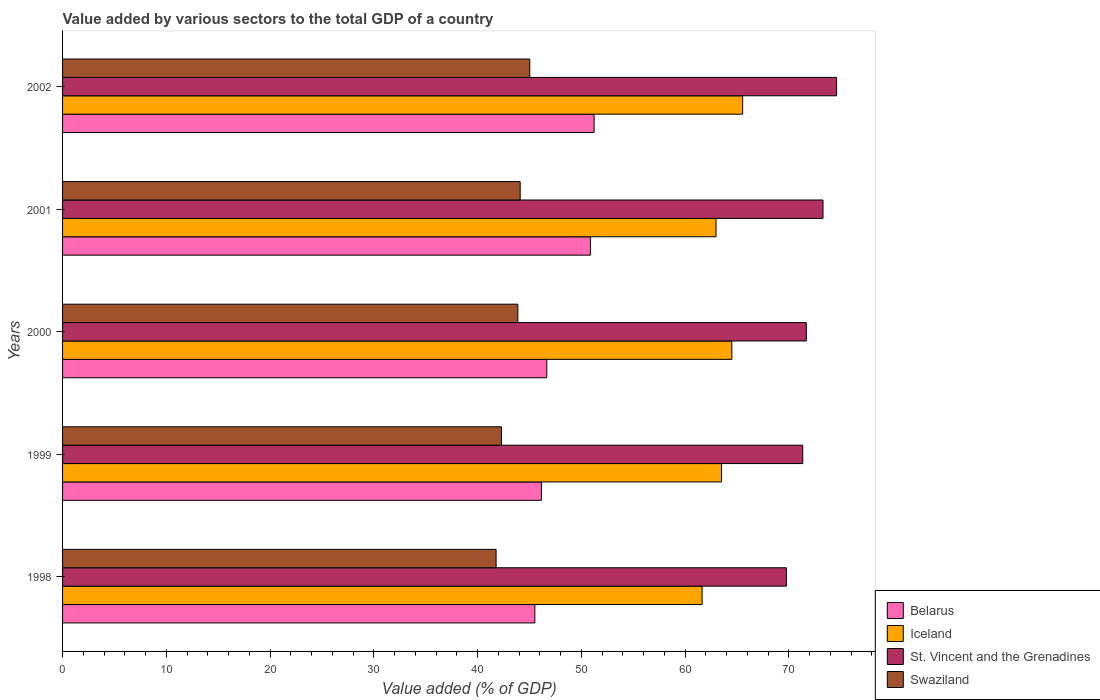How many groups of bars are there?
Make the answer very short. 5. Are the number of bars on each tick of the Y-axis equal?
Ensure brevity in your answer.  Yes. How many bars are there on the 1st tick from the top?
Give a very brief answer. 4. What is the label of the 1st group of bars from the top?
Provide a short and direct response. 2002. What is the value added by various sectors to the total GDP in Iceland in 2002?
Provide a succinct answer. 65.56. Across all years, what is the maximum value added by various sectors to the total GDP in Swaziland?
Give a very brief answer. 45.04. Across all years, what is the minimum value added by various sectors to the total GDP in Belarus?
Give a very brief answer. 45.52. What is the total value added by various sectors to the total GDP in St. Vincent and the Grenadines in the graph?
Offer a very short reply. 360.72. What is the difference between the value added by various sectors to the total GDP in St. Vincent and the Grenadines in 1999 and that in 2002?
Offer a very short reply. -3.26. What is the difference between the value added by various sectors to the total GDP in St. Vincent and the Grenadines in 2001 and the value added by various sectors to the total GDP in Iceland in 1999?
Keep it short and to the point. 9.78. What is the average value added by various sectors to the total GDP in St. Vincent and the Grenadines per year?
Offer a very short reply. 72.14. In the year 2001, what is the difference between the value added by various sectors to the total GDP in St. Vincent and the Grenadines and value added by various sectors to the total GDP in Swaziland?
Your answer should be very brief. 29.19. In how many years, is the value added by various sectors to the total GDP in Iceland greater than 44 %?
Make the answer very short. 5. What is the ratio of the value added by various sectors to the total GDP in Swaziland in 1998 to that in 2000?
Give a very brief answer. 0.95. Is the difference between the value added by various sectors to the total GDP in St. Vincent and the Grenadines in 2000 and 2001 greater than the difference between the value added by various sectors to the total GDP in Swaziland in 2000 and 2001?
Ensure brevity in your answer.  No. What is the difference between the highest and the second highest value added by various sectors to the total GDP in Belarus?
Your answer should be very brief. 0.36. What is the difference between the highest and the lowest value added by various sectors to the total GDP in Iceland?
Your answer should be compact. 3.91. Is it the case that in every year, the sum of the value added by various sectors to the total GDP in Swaziland and value added by various sectors to the total GDP in Iceland is greater than the sum of value added by various sectors to the total GDP in St. Vincent and the Grenadines and value added by various sectors to the total GDP in Belarus?
Your response must be concise. Yes. What does the 2nd bar from the top in 1999 represents?
Offer a terse response. St. Vincent and the Grenadines. Is it the case that in every year, the sum of the value added by various sectors to the total GDP in St. Vincent and the Grenadines and value added by various sectors to the total GDP in Swaziland is greater than the value added by various sectors to the total GDP in Iceland?
Offer a very short reply. Yes. How many bars are there?
Your answer should be very brief. 20. Are all the bars in the graph horizontal?
Offer a very short reply. Yes. How many years are there in the graph?
Offer a very short reply. 5. What is the difference between two consecutive major ticks on the X-axis?
Ensure brevity in your answer.  10. Are the values on the major ticks of X-axis written in scientific E-notation?
Make the answer very short. No. Does the graph contain any zero values?
Your answer should be compact. No. How many legend labels are there?
Offer a very short reply. 4. What is the title of the graph?
Offer a very short reply. Value added by various sectors to the total GDP of a country. Does "South Sudan" appear as one of the legend labels in the graph?
Provide a succinct answer. No. What is the label or title of the X-axis?
Your response must be concise. Value added (% of GDP). What is the label or title of the Y-axis?
Give a very brief answer. Years. What is the Value added (% of GDP) in Belarus in 1998?
Make the answer very short. 45.52. What is the Value added (% of GDP) of Iceland in 1998?
Give a very brief answer. 61.65. What is the Value added (% of GDP) in St. Vincent and the Grenadines in 1998?
Provide a succinct answer. 69.77. What is the Value added (% of GDP) of Swaziland in 1998?
Your answer should be compact. 41.79. What is the Value added (% of GDP) of Belarus in 1999?
Offer a very short reply. 46.16. What is the Value added (% of GDP) of Iceland in 1999?
Give a very brief answer. 63.52. What is the Value added (% of GDP) of St. Vincent and the Grenadines in 1999?
Your answer should be compact. 71.35. What is the Value added (% of GDP) of Swaziland in 1999?
Your answer should be compact. 42.31. What is the Value added (% of GDP) of Belarus in 2000?
Offer a terse response. 46.68. What is the Value added (% of GDP) of Iceland in 2000?
Give a very brief answer. 64.51. What is the Value added (% of GDP) in St. Vincent and the Grenadines in 2000?
Ensure brevity in your answer.  71.69. What is the Value added (% of GDP) in Swaziland in 2000?
Offer a very short reply. 43.88. What is the Value added (% of GDP) of Belarus in 2001?
Your answer should be very brief. 50.88. What is the Value added (% of GDP) of Iceland in 2001?
Your response must be concise. 62.99. What is the Value added (% of GDP) of St. Vincent and the Grenadines in 2001?
Provide a short and direct response. 73.3. What is the Value added (% of GDP) of Swaziland in 2001?
Give a very brief answer. 44.11. What is the Value added (% of GDP) in Belarus in 2002?
Provide a succinct answer. 51.24. What is the Value added (% of GDP) of Iceland in 2002?
Keep it short and to the point. 65.56. What is the Value added (% of GDP) in St. Vincent and the Grenadines in 2002?
Offer a very short reply. 74.61. What is the Value added (% of GDP) in Swaziland in 2002?
Your response must be concise. 45.04. Across all years, what is the maximum Value added (% of GDP) of Belarus?
Your answer should be compact. 51.24. Across all years, what is the maximum Value added (% of GDP) of Iceland?
Your answer should be very brief. 65.56. Across all years, what is the maximum Value added (% of GDP) of St. Vincent and the Grenadines?
Keep it short and to the point. 74.61. Across all years, what is the maximum Value added (% of GDP) of Swaziland?
Offer a terse response. 45.04. Across all years, what is the minimum Value added (% of GDP) in Belarus?
Make the answer very short. 45.52. Across all years, what is the minimum Value added (% of GDP) of Iceland?
Give a very brief answer. 61.65. Across all years, what is the minimum Value added (% of GDP) in St. Vincent and the Grenadines?
Your answer should be very brief. 69.77. Across all years, what is the minimum Value added (% of GDP) in Swaziland?
Provide a short and direct response. 41.79. What is the total Value added (% of GDP) of Belarus in the graph?
Your answer should be very brief. 240.47. What is the total Value added (% of GDP) of Iceland in the graph?
Make the answer very short. 318.22. What is the total Value added (% of GDP) of St. Vincent and the Grenadines in the graph?
Offer a terse response. 360.72. What is the total Value added (% of GDP) in Swaziland in the graph?
Provide a succinct answer. 217.13. What is the difference between the Value added (% of GDP) of Belarus in 1998 and that in 1999?
Give a very brief answer. -0.63. What is the difference between the Value added (% of GDP) in Iceland in 1998 and that in 1999?
Keep it short and to the point. -1.87. What is the difference between the Value added (% of GDP) in St. Vincent and the Grenadines in 1998 and that in 1999?
Your response must be concise. -1.58. What is the difference between the Value added (% of GDP) in Swaziland in 1998 and that in 1999?
Offer a terse response. -0.52. What is the difference between the Value added (% of GDP) of Belarus in 1998 and that in 2000?
Offer a very short reply. -1.15. What is the difference between the Value added (% of GDP) in Iceland in 1998 and that in 2000?
Provide a short and direct response. -2.87. What is the difference between the Value added (% of GDP) in St. Vincent and the Grenadines in 1998 and that in 2000?
Keep it short and to the point. -1.92. What is the difference between the Value added (% of GDP) of Swaziland in 1998 and that in 2000?
Your answer should be compact. -2.1. What is the difference between the Value added (% of GDP) of Belarus in 1998 and that in 2001?
Offer a very short reply. -5.36. What is the difference between the Value added (% of GDP) of Iceland in 1998 and that in 2001?
Ensure brevity in your answer.  -1.34. What is the difference between the Value added (% of GDP) of St. Vincent and the Grenadines in 1998 and that in 2001?
Offer a very short reply. -3.53. What is the difference between the Value added (% of GDP) of Swaziland in 1998 and that in 2001?
Offer a very short reply. -2.32. What is the difference between the Value added (% of GDP) in Belarus in 1998 and that in 2002?
Keep it short and to the point. -5.71. What is the difference between the Value added (% of GDP) of Iceland in 1998 and that in 2002?
Offer a very short reply. -3.91. What is the difference between the Value added (% of GDP) of St. Vincent and the Grenadines in 1998 and that in 2002?
Offer a very short reply. -4.84. What is the difference between the Value added (% of GDP) in Swaziland in 1998 and that in 2002?
Provide a succinct answer. -3.25. What is the difference between the Value added (% of GDP) in Belarus in 1999 and that in 2000?
Offer a very short reply. -0.52. What is the difference between the Value added (% of GDP) in Iceland in 1999 and that in 2000?
Give a very brief answer. -0.99. What is the difference between the Value added (% of GDP) of St. Vincent and the Grenadines in 1999 and that in 2000?
Your response must be concise. -0.35. What is the difference between the Value added (% of GDP) in Swaziland in 1999 and that in 2000?
Your answer should be compact. -1.58. What is the difference between the Value added (% of GDP) in Belarus in 1999 and that in 2001?
Offer a very short reply. -4.72. What is the difference between the Value added (% of GDP) of Iceland in 1999 and that in 2001?
Offer a very short reply. 0.53. What is the difference between the Value added (% of GDP) in St. Vincent and the Grenadines in 1999 and that in 2001?
Provide a short and direct response. -1.95. What is the difference between the Value added (% of GDP) of Swaziland in 1999 and that in 2001?
Keep it short and to the point. -1.8. What is the difference between the Value added (% of GDP) in Belarus in 1999 and that in 2002?
Your response must be concise. -5.08. What is the difference between the Value added (% of GDP) of Iceland in 1999 and that in 2002?
Keep it short and to the point. -2.04. What is the difference between the Value added (% of GDP) of St. Vincent and the Grenadines in 1999 and that in 2002?
Your answer should be very brief. -3.26. What is the difference between the Value added (% of GDP) in Swaziland in 1999 and that in 2002?
Give a very brief answer. -2.73. What is the difference between the Value added (% of GDP) in Belarus in 2000 and that in 2001?
Your response must be concise. -4.2. What is the difference between the Value added (% of GDP) of Iceland in 2000 and that in 2001?
Offer a very short reply. 1.52. What is the difference between the Value added (% of GDP) in St. Vincent and the Grenadines in 2000 and that in 2001?
Make the answer very short. -1.61. What is the difference between the Value added (% of GDP) in Swaziland in 2000 and that in 2001?
Your answer should be very brief. -0.23. What is the difference between the Value added (% of GDP) in Belarus in 2000 and that in 2002?
Offer a terse response. -4.56. What is the difference between the Value added (% of GDP) of Iceland in 2000 and that in 2002?
Keep it short and to the point. -1.04. What is the difference between the Value added (% of GDP) of St. Vincent and the Grenadines in 2000 and that in 2002?
Make the answer very short. -2.92. What is the difference between the Value added (% of GDP) of Swaziland in 2000 and that in 2002?
Provide a succinct answer. -1.15. What is the difference between the Value added (% of GDP) in Belarus in 2001 and that in 2002?
Your answer should be very brief. -0.36. What is the difference between the Value added (% of GDP) in Iceland in 2001 and that in 2002?
Provide a succinct answer. -2.57. What is the difference between the Value added (% of GDP) of St. Vincent and the Grenadines in 2001 and that in 2002?
Your response must be concise. -1.31. What is the difference between the Value added (% of GDP) in Swaziland in 2001 and that in 2002?
Your answer should be compact. -0.93. What is the difference between the Value added (% of GDP) of Belarus in 1998 and the Value added (% of GDP) of Iceland in 1999?
Offer a very short reply. -18. What is the difference between the Value added (% of GDP) of Belarus in 1998 and the Value added (% of GDP) of St. Vincent and the Grenadines in 1999?
Your response must be concise. -25.82. What is the difference between the Value added (% of GDP) of Belarus in 1998 and the Value added (% of GDP) of Swaziland in 1999?
Your answer should be compact. 3.22. What is the difference between the Value added (% of GDP) in Iceland in 1998 and the Value added (% of GDP) in St. Vincent and the Grenadines in 1999?
Offer a very short reply. -9.7. What is the difference between the Value added (% of GDP) in Iceland in 1998 and the Value added (% of GDP) in Swaziland in 1999?
Keep it short and to the point. 19.34. What is the difference between the Value added (% of GDP) of St. Vincent and the Grenadines in 1998 and the Value added (% of GDP) of Swaziland in 1999?
Your response must be concise. 27.46. What is the difference between the Value added (% of GDP) in Belarus in 1998 and the Value added (% of GDP) in Iceland in 2000?
Provide a short and direct response. -18.99. What is the difference between the Value added (% of GDP) of Belarus in 1998 and the Value added (% of GDP) of St. Vincent and the Grenadines in 2000?
Keep it short and to the point. -26.17. What is the difference between the Value added (% of GDP) in Belarus in 1998 and the Value added (% of GDP) in Swaziland in 2000?
Provide a short and direct response. 1.64. What is the difference between the Value added (% of GDP) of Iceland in 1998 and the Value added (% of GDP) of St. Vincent and the Grenadines in 2000?
Ensure brevity in your answer.  -10.05. What is the difference between the Value added (% of GDP) in Iceland in 1998 and the Value added (% of GDP) in Swaziland in 2000?
Your answer should be very brief. 17.76. What is the difference between the Value added (% of GDP) of St. Vincent and the Grenadines in 1998 and the Value added (% of GDP) of Swaziland in 2000?
Ensure brevity in your answer.  25.89. What is the difference between the Value added (% of GDP) of Belarus in 1998 and the Value added (% of GDP) of Iceland in 2001?
Make the answer very short. -17.46. What is the difference between the Value added (% of GDP) of Belarus in 1998 and the Value added (% of GDP) of St. Vincent and the Grenadines in 2001?
Keep it short and to the point. -27.78. What is the difference between the Value added (% of GDP) in Belarus in 1998 and the Value added (% of GDP) in Swaziland in 2001?
Provide a short and direct response. 1.41. What is the difference between the Value added (% of GDP) of Iceland in 1998 and the Value added (% of GDP) of St. Vincent and the Grenadines in 2001?
Ensure brevity in your answer.  -11.66. What is the difference between the Value added (% of GDP) of Iceland in 1998 and the Value added (% of GDP) of Swaziland in 2001?
Ensure brevity in your answer.  17.54. What is the difference between the Value added (% of GDP) of St. Vincent and the Grenadines in 1998 and the Value added (% of GDP) of Swaziland in 2001?
Offer a terse response. 25.66. What is the difference between the Value added (% of GDP) of Belarus in 1998 and the Value added (% of GDP) of Iceland in 2002?
Offer a terse response. -20.03. What is the difference between the Value added (% of GDP) in Belarus in 1998 and the Value added (% of GDP) in St. Vincent and the Grenadines in 2002?
Your answer should be very brief. -29.09. What is the difference between the Value added (% of GDP) of Belarus in 1998 and the Value added (% of GDP) of Swaziland in 2002?
Provide a short and direct response. 0.49. What is the difference between the Value added (% of GDP) in Iceland in 1998 and the Value added (% of GDP) in St. Vincent and the Grenadines in 2002?
Make the answer very short. -12.96. What is the difference between the Value added (% of GDP) of Iceland in 1998 and the Value added (% of GDP) of Swaziland in 2002?
Make the answer very short. 16.61. What is the difference between the Value added (% of GDP) in St. Vincent and the Grenadines in 1998 and the Value added (% of GDP) in Swaziland in 2002?
Your answer should be very brief. 24.73. What is the difference between the Value added (% of GDP) of Belarus in 1999 and the Value added (% of GDP) of Iceland in 2000?
Your answer should be compact. -18.36. What is the difference between the Value added (% of GDP) of Belarus in 1999 and the Value added (% of GDP) of St. Vincent and the Grenadines in 2000?
Make the answer very short. -25.54. What is the difference between the Value added (% of GDP) in Belarus in 1999 and the Value added (% of GDP) in Swaziland in 2000?
Keep it short and to the point. 2.27. What is the difference between the Value added (% of GDP) in Iceland in 1999 and the Value added (% of GDP) in St. Vincent and the Grenadines in 2000?
Offer a terse response. -8.17. What is the difference between the Value added (% of GDP) of Iceland in 1999 and the Value added (% of GDP) of Swaziland in 2000?
Your response must be concise. 19.63. What is the difference between the Value added (% of GDP) of St. Vincent and the Grenadines in 1999 and the Value added (% of GDP) of Swaziland in 2000?
Offer a terse response. 27.46. What is the difference between the Value added (% of GDP) of Belarus in 1999 and the Value added (% of GDP) of Iceland in 2001?
Make the answer very short. -16.83. What is the difference between the Value added (% of GDP) of Belarus in 1999 and the Value added (% of GDP) of St. Vincent and the Grenadines in 2001?
Provide a short and direct response. -27.15. What is the difference between the Value added (% of GDP) of Belarus in 1999 and the Value added (% of GDP) of Swaziland in 2001?
Ensure brevity in your answer.  2.05. What is the difference between the Value added (% of GDP) in Iceland in 1999 and the Value added (% of GDP) in St. Vincent and the Grenadines in 2001?
Your response must be concise. -9.78. What is the difference between the Value added (% of GDP) of Iceland in 1999 and the Value added (% of GDP) of Swaziland in 2001?
Make the answer very short. 19.41. What is the difference between the Value added (% of GDP) in St. Vincent and the Grenadines in 1999 and the Value added (% of GDP) in Swaziland in 2001?
Your answer should be very brief. 27.24. What is the difference between the Value added (% of GDP) in Belarus in 1999 and the Value added (% of GDP) in Iceland in 2002?
Make the answer very short. -19.4. What is the difference between the Value added (% of GDP) of Belarus in 1999 and the Value added (% of GDP) of St. Vincent and the Grenadines in 2002?
Provide a short and direct response. -28.45. What is the difference between the Value added (% of GDP) of Belarus in 1999 and the Value added (% of GDP) of Swaziland in 2002?
Give a very brief answer. 1.12. What is the difference between the Value added (% of GDP) of Iceland in 1999 and the Value added (% of GDP) of St. Vincent and the Grenadines in 2002?
Your answer should be very brief. -11.09. What is the difference between the Value added (% of GDP) of Iceland in 1999 and the Value added (% of GDP) of Swaziland in 2002?
Ensure brevity in your answer.  18.48. What is the difference between the Value added (% of GDP) in St. Vincent and the Grenadines in 1999 and the Value added (% of GDP) in Swaziland in 2002?
Make the answer very short. 26.31. What is the difference between the Value added (% of GDP) in Belarus in 2000 and the Value added (% of GDP) in Iceland in 2001?
Your answer should be very brief. -16.31. What is the difference between the Value added (% of GDP) in Belarus in 2000 and the Value added (% of GDP) in St. Vincent and the Grenadines in 2001?
Provide a short and direct response. -26.63. What is the difference between the Value added (% of GDP) of Belarus in 2000 and the Value added (% of GDP) of Swaziland in 2001?
Give a very brief answer. 2.57. What is the difference between the Value added (% of GDP) in Iceland in 2000 and the Value added (% of GDP) in St. Vincent and the Grenadines in 2001?
Offer a terse response. -8.79. What is the difference between the Value added (% of GDP) in Iceland in 2000 and the Value added (% of GDP) in Swaziland in 2001?
Provide a short and direct response. 20.4. What is the difference between the Value added (% of GDP) in St. Vincent and the Grenadines in 2000 and the Value added (% of GDP) in Swaziland in 2001?
Make the answer very short. 27.58. What is the difference between the Value added (% of GDP) of Belarus in 2000 and the Value added (% of GDP) of Iceland in 2002?
Provide a short and direct response. -18.88. What is the difference between the Value added (% of GDP) in Belarus in 2000 and the Value added (% of GDP) in St. Vincent and the Grenadines in 2002?
Provide a succinct answer. -27.93. What is the difference between the Value added (% of GDP) in Belarus in 2000 and the Value added (% of GDP) in Swaziland in 2002?
Give a very brief answer. 1.64. What is the difference between the Value added (% of GDP) of Iceland in 2000 and the Value added (% of GDP) of St. Vincent and the Grenadines in 2002?
Make the answer very short. -10.1. What is the difference between the Value added (% of GDP) in Iceland in 2000 and the Value added (% of GDP) in Swaziland in 2002?
Ensure brevity in your answer.  19.48. What is the difference between the Value added (% of GDP) in St. Vincent and the Grenadines in 2000 and the Value added (% of GDP) in Swaziland in 2002?
Your answer should be compact. 26.66. What is the difference between the Value added (% of GDP) in Belarus in 2001 and the Value added (% of GDP) in Iceland in 2002?
Offer a terse response. -14.68. What is the difference between the Value added (% of GDP) in Belarus in 2001 and the Value added (% of GDP) in St. Vincent and the Grenadines in 2002?
Your answer should be compact. -23.73. What is the difference between the Value added (% of GDP) in Belarus in 2001 and the Value added (% of GDP) in Swaziland in 2002?
Make the answer very short. 5.84. What is the difference between the Value added (% of GDP) in Iceland in 2001 and the Value added (% of GDP) in St. Vincent and the Grenadines in 2002?
Your answer should be compact. -11.62. What is the difference between the Value added (% of GDP) of Iceland in 2001 and the Value added (% of GDP) of Swaziland in 2002?
Provide a succinct answer. 17.95. What is the difference between the Value added (% of GDP) of St. Vincent and the Grenadines in 2001 and the Value added (% of GDP) of Swaziland in 2002?
Give a very brief answer. 28.27. What is the average Value added (% of GDP) of Belarus per year?
Offer a terse response. 48.09. What is the average Value added (% of GDP) in Iceland per year?
Give a very brief answer. 63.64. What is the average Value added (% of GDP) in St. Vincent and the Grenadines per year?
Provide a succinct answer. 72.14. What is the average Value added (% of GDP) in Swaziland per year?
Your response must be concise. 43.43. In the year 1998, what is the difference between the Value added (% of GDP) in Belarus and Value added (% of GDP) in Iceland?
Provide a succinct answer. -16.12. In the year 1998, what is the difference between the Value added (% of GDP) in Belarus and Value added (% of GDP) in St. Vincent and the Grenadines?
Provide a succinct answer. -24.25. In the year 1998, what is the difference between the Value added (% of GDP) of Belarus and Value added (% of GDP) of Swaziland?
Provide a succinct answer. 3.74. In the year 1998, what is the difference between the Value added (% of GDP) of Iceland and Value added (% of GDP) of St. Vincent and the Grenadines?
Your response must be concise. -8.12. In the year 1998, what is the difference between the Value added (% of GDP) in Iceland and Value added (% of GDP) in Swaziland?
Ensure brevity in your answer.  19.86. In the year 1998, what is the difference between the Value added (% of GDP) of St. Vincent and the Grenadines and Value added (% of GDP) of Swaziland?
Give a very brief answer. 27.98. In the year 1999, what is the difference between the Value added (% of GDP) in Belarus and Value added (% of GDP) in Iceland?
Provide a succinct answer. -17.36. In the year 1999, what is the difference between the Value added (% of GDP) in Belarus and Value added (% of GDP) in St. Vincent and the Grenadines?
Make the answer very short. -25.19. In the year 1999, what is the difference between the Value added (% of GDP) in Belarus and Value added (% of GDP) in Swaziland?
Your answer should be very brief. 3.85. In the year 1999, what is the difference between the Value added (% of GDP) in Iceland and Value added (% of GDP) in St. Vincent and the Grenadines?
Offer a terse response. -7.83. In the year 1999, what is the difference between the Value added (% of GDP) of Iceland and Value added (% of GDP) of Swaziland?
Your answer should be very brief. 21.21. In the year 1999, what is the difference between the Value added (% of GDP) of St. Vincent and the Grenadines and Value added (% of GDP) of Swaziland?
Offer a terse response. 29.04. In the year 2000, what is the difference between the Value added (% of GDP) in Belarus and Value added (% of GDP) in Iceland?
Keep it short and to the point. -17.84. In the year 2000, what is the difference between the Value added (% of GDP) in Belarus and Value added (% of GDP) in St. Vincent and the Grenadines?
Make the answer very short. -25.02. In the year 2000, what is the difference between the Value added (% of GDP) in Belarus and Value added (% of GDP) in Swaziland?
Provide a succinct answer. 2.79. In the year 2000, what is the difference between the Value added (% of GDP) in Iceland and Value added (% of GDP) in St. Vincent and the Grenadines?
Offer a terse response. -7.18. In the year 2000, what is the difference between the Value added (% of GDP) in Iceland and Value added (% of GDP) in Swaziland?
Provide a succinct answer. 20.63. In the year 2000, what is the difference between the Value added (% of GDP) of St. Vincent and the Grenadines and Value added (% of GDP) of Swaziland?
Make the answer very short. 27.81. In the year 2001, what is the difference between the Value added (% of GDP) of Belarus and Value added (% of GDP) of Iceland?
Your answer should be very brief. -12.11. In the year 2001, what is the difference between the Value added (% of GDP) of Belarus and Value added (% of GDP) of St. Vincent and the Grenadines?
Offer a very short reply. -22.42. In the year 2001, what is the difference between the Value added (% of GDP) of Belarus and Value added (% of GDP) of Swaziland?
Give a very brief answer. 6.77. In the year 2001, what is the difference between the Value added (% of GDP) in Iceland and Value added (% of GDP) in St. Vincent and the Grenadines?
Ensure brevity in your answer.  -10.31. In the year 2001, what is the difference between the Value added (% of GDP) in Iceland and Value added (% of GDP) in Swaziland?
Your answer should be compact. 18.88. In the year 2001, what is the difference between the Value added (% of GDP) in St. Vincent and the Grenadines and Value added (% of GDP) in Swaziland?
Ensure brevity in your answer.  29.19. In the year 2002, what is the difference between the Value added (% of GDP) of Belarus and Value added (% of GDP) of Iceland?
Give a very brief answer. -14.32. In the year 2002, what is the difference between the Value added (% of GDP) in Belarus and Value added (% of GDP) in St. Vincent and the Grenadines?
Make the answer very short. -23.37. In the year 2002, what is the difference between the Value added (% of GDP) in Belarus and Value added (% of GDP) in Swaziland?
Your answer should be compact. 6.2. In the year 2002, what is the difference between the Value added (% of GDP) in Iceland and Value added (% of GDP) in St. Vincent and the Grenadines?
Offer a terse response. -9.05. In the year 2002, what is the difference between the Value added (% of GDP) of Iceland and Value added (% of GDP) of Swaziland?
Keep it short and to the point. 20.52. In the year 2002, what is the difference between the Value added (% of GDP) of St. Vincent and the Grenadines and Value added (% of GDP) of Swaziland?
Give a very brief answer. 29.57. What is the ratio of the Value added (% of GDP) in Belarus in 1998 to that in 1999?
Provide a short and direct response. 0.99. What is the ratio of the Value added (% of GDP) in Iceland in 1998 to that in 1999?
Offer a very short reply. 0.97. What is the ratio of the Value added (% of GDP) of St. Vincent and the Grenadines in 1998 to that in 1999?
Offer a very short reply. 0.98. What is the ratio of the Value added (% of GDP) in Swaziland in 1998 to that in 1999?
Your answer should be very brief. 0.99. What is the ratio of the Value added (% of GDP) of Belarus in 1998 to that in 2000?
Your answer should be compact. 0.98. What is the ratio of the Value added (% of GDP) of Iceland in 1998 to that in 2000?
Give a very brief answer. 0.96. What is the ratio of the Value added (% of GDP) in St. Vincent and the Grenadines in 1998 to that in 2000?
Provide a short and direct response. 0.97. What is the ratio of the Value added (% of GDP) of Swaziland in 1998 to that in 2000?
Keep it short and to the point. 0.95. What is the ratio of the Value added (% of GDP) of Belarus in 1998 to that in 2001?
Ensure brevity in your answer.  0.89. What is the ratio of the Value added (% of GDP) of Iceland in 1998 to that in 2001?
Your answer should be very brief. 0.98. What is the ratio of the Value added (% of GDP) of St. Vincent and the Grenadines in 1998 to that in 2001?
Keep it short and to the point. 0.95. What is the ratio of the Value added (% of GDP) in Swaziland in 1998 to that in 2001?
Ensure brevity in your answer.  0.95. What is the ratio of the Value added (% of GDP) in Belarus in 1998 to that in 2002?
Provide a short and direct response. 0.89. What is the ratio of the Value added (% of GDP) of Iceland in 1998 to that in 2002?
Keep it short and to the point. 0.94. What is the ratio of the Value added (% of GDP) in St. Vincent and the Grenadines in 1998 to that in 2002?
Provide a succinct answer. 0.94. What is the ratio of the Value added (% of GDP) of Swaziland in 1998 to that in 2002?
Your response must be concise. 0.93. What is the ratio of the Value added (% of GDP) of Belarus in 1999 to that in 2000?
Offer a very short reply. 0.99. What is the ratio of the Value added (% of GDP) in Iceland in 1999 to that in 2000?
Offer a very short reply. 0.98. What is the ratio of the Value added (% of GDP) in Swaziland in 1999 to that in 2000?
Offer a terse response. 0.96. What is the ratio of the Value added (% of GDP) in Belarus in 1999 to that in 2001?
Offer a terse response. 0.91. What is the ratio of the Value added (% of GDP) in Iceland in 1999 to that in 2001?
Provide a succinct answer. 1.01. What is the ratio of the Value added (% of GDP) of St. Vincent and the Grenadines in 1999 to that in 2001?
Provide a succinct answer. 0.97. What is the ratio of the Value added (% of GDP) in Swaziland in 1999 to that in 2001?
Provide a succinct answer. 0.96. What is the ratio of the Value added (% of GDP) in Belarus in 1999 to that in 2002?
Ensure brevity in your answer.  0.9. What is the ratio of the Value added (% of GDP) of Iceland in 1999 to that in 2002?
Your answer should be compact. 0.97. What is the ratio of the Value added (% of GDP) of St. Vincent and the Grenadines in 1999 to that in 2002?
Keep it short and to the point. 0.96. What is the ratio of the Value added (% of GDP) in Swaziland in 1999 to that in 2002?
Ensure brevity in your answer.  0.94. What is the ratio of the Value added (% of GDP) of Belarus in 2000 to that in 2001?
Ensure brevity in your answer.  0.92. What is the ratio of the Value added (% of GDP) in Iceland in 2000 to that in 2001?
Your response must be concise. 1.02. What is the ratio of the Value added (% of GDP) in St. Vincent and the Grenadines in 2000 to that in 2001?
Your response must be concise. 0.98. What is the ratio of the Value added (% of GDP) in Swaziland in 2000 to that in 2001?
Make the answer very short. 0.99. What is the ratio of the Value added (% of GDP) in Belarus in 2000 to that in 2002?
Ensure brevity in your answer.  0.91. What is the ratio of the Value added (% of GDP) in Iceland in 2000 to that in 2002?
Keep it short and to the point. 0.98. What is the ratio of the Value added (% of GDP) of St. Vincent and the Grenadines in 2000 to that in 2002?
Your response must be concise. 0.96. What is the ratio of the Value added (% of GDP) in Swaziland in 2000 to that in 2002?
Ensure brevity in your answer.  0.97. What is the ratio of the Value added (% of GDP) of Iceland in 2001 to that in 2002?
Your answer should be very brief. 0.96. What is the ratio of the Value added (% of GDP) in St. Vincent and the Grenadines in 2001 to that in 2002?
Give a very brief answer. 0.98. What is the ratio of the Value added (% of GDP) in Swaziland in 2001 to that in 2002?
Ensure brevity in your answer.  0.98. What is the difference between the highest and the second highest Value added (% of GDP) in Belarus?
Ensure brevity in your answer.  0.36. What is the difference between the highest and the second highest Value added (% of GDP) in Iceland?
Your answer should be compact. 1.04. What is the difference between the highest and the second highest Value added (% of GDP) in St. Vincent and the Grenadines?
Make the answer very short. 1.31. What is the difference between the highest and the second highest Value added (% of GDP) of Swaziland?
Keep it short and to the point. 0.93. What is the difference between the highest and the lowest Value added (% of GDP) of Belarus?
Provide a succinct answer. 5.71. What is the difference between the highest and the lowest Value added (% of GDP) of Iceland?
Your answer should be very brief. 3.91. What is the difference between the highest and the lowest Value added (% of GDP) in St. Vincent and the Grenadines?
Keep it short and to the point. 4.84. What is the difference between the highest and the lowest Value added (% of GDP) of Swaziland?
Make the answer very short. 3.25. 